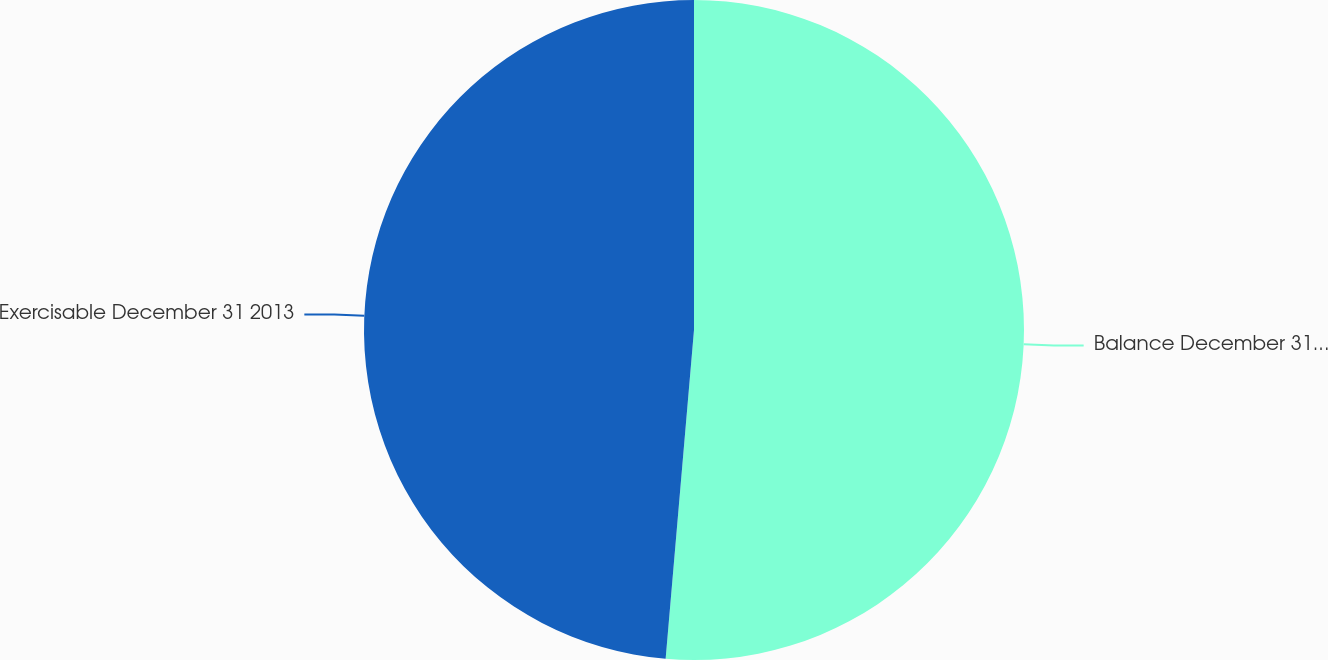Convert chart to OTSL. <chart><loc_0><loc_0><loc_500><loc_500><pie_chart><fcel>Balance December 31 2013<fcel>Exercisable December 31 2013<nl><fcel>51.37%<fcel>48.63%<nl></chart> 